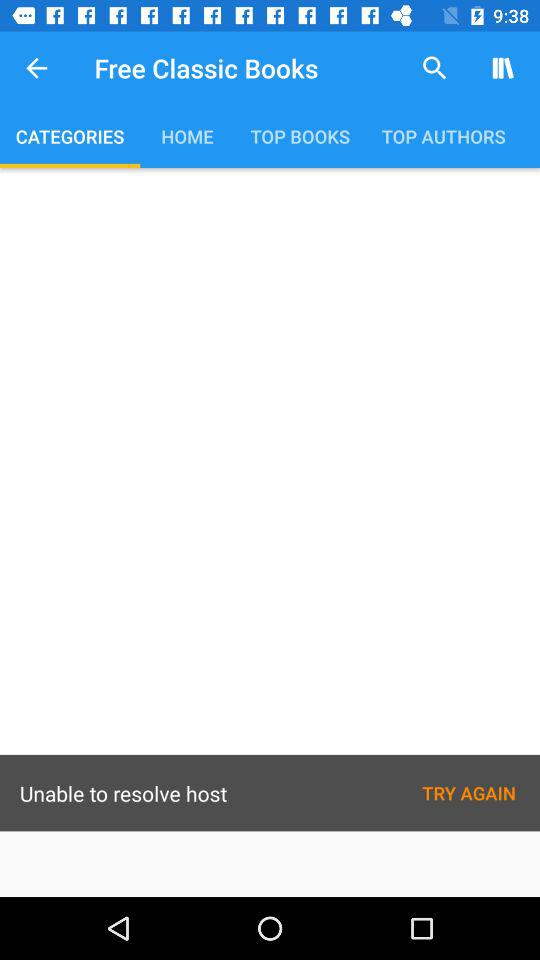Which tab is selected? The selected tab is "CATEGORIES". 